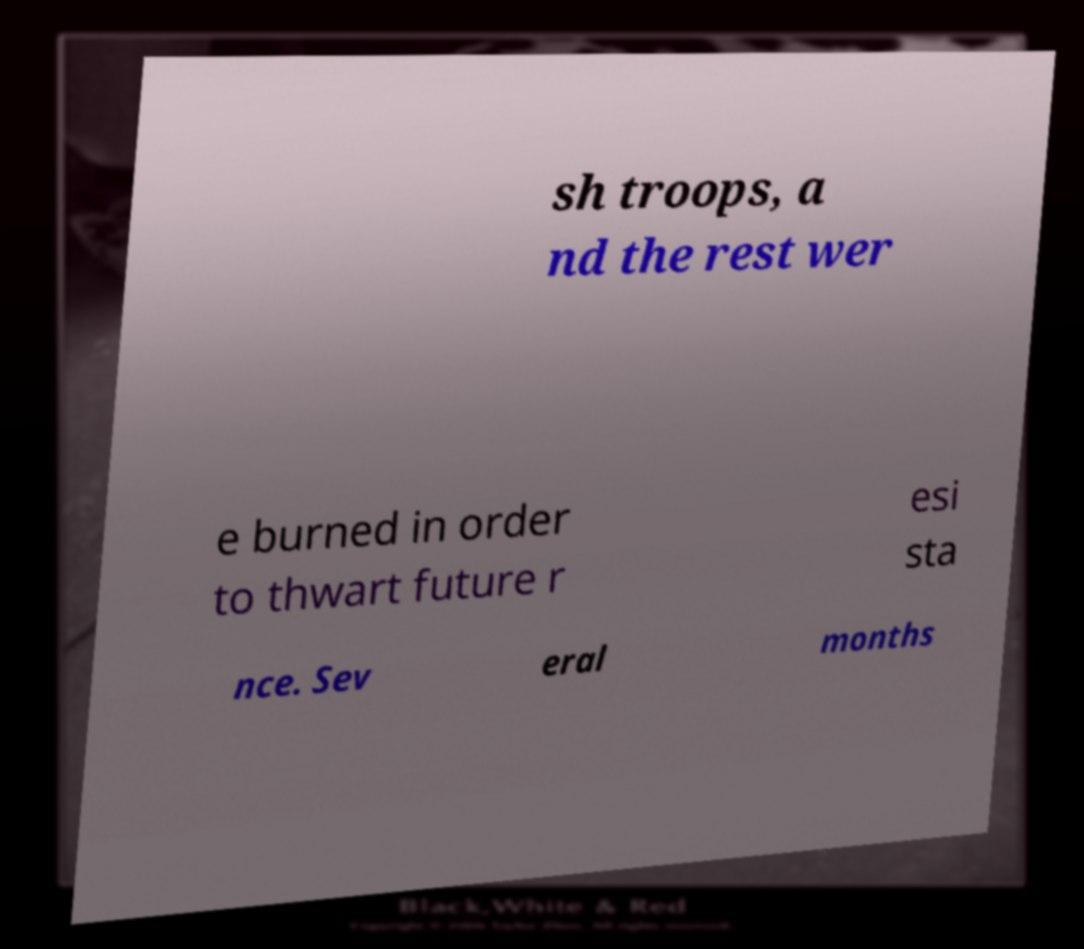There's text embedded in this image that I need extracted. Can you transcribe it verbatim? sh troops, a nd the rest wer e burned in order to thwart future r esi sta nce. Sev eral months 